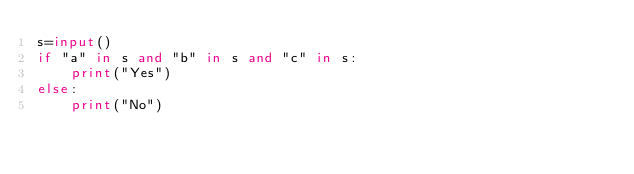Convert code to text. <code><loc_0><loc_0><loc_500><loc_500><_Python_>s=input()
if "a" in s and "b" in s and "c" in s:
    print("Yes")
else:
    print("No")</code> 